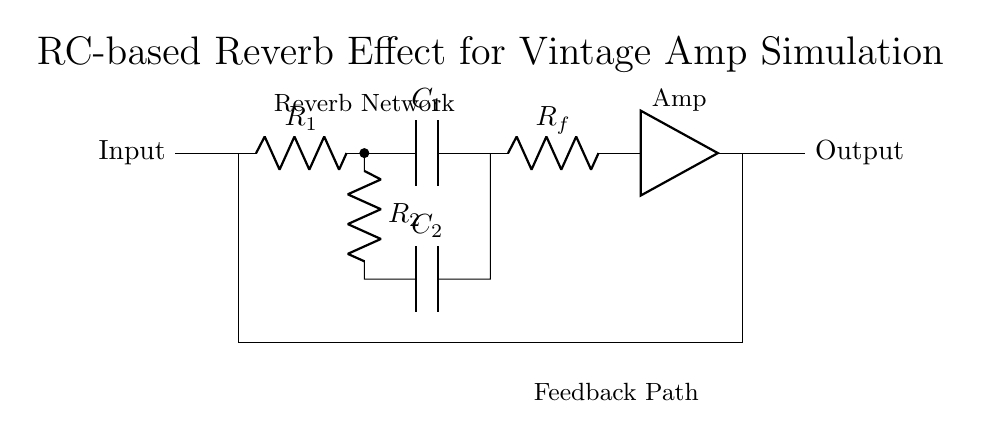What type of components are present in this circuit? The circuit contains resistors and capacitors, which are indicated by the symbols R and C respectively.
Answer: Resistors and capacitors What does the feedback path consist of? The feedback path includes a resistor (R_f) and a connection back to the input through the amp, creating a loop for the signal.
Answer: Resistor and amp How many resistors are in the circuit? There are three resistors shown in the circuit diagram: R1, R2, and R_f.
Answer: Three What is the role of capacitors in this reverb circuit? Capacitors in this circuit provide filtering properties and contribute to the delay effect which is essential for reverb sound.
Answer: Filtering and delay What happens to the signal as it passes through the RC network? The signal experiences attenuation and phase shift due to the combination of resistors and capacitors in the network, which creates an echo effect essential for reverb.
Answer: Attenuation and phase shift What can be inferred about the configuration of R2 and C2? R2 and C2 are in parallel within the circuit, which influences the time constant and responsiveness of the reverb effect.
Answer: Parallel configuration 